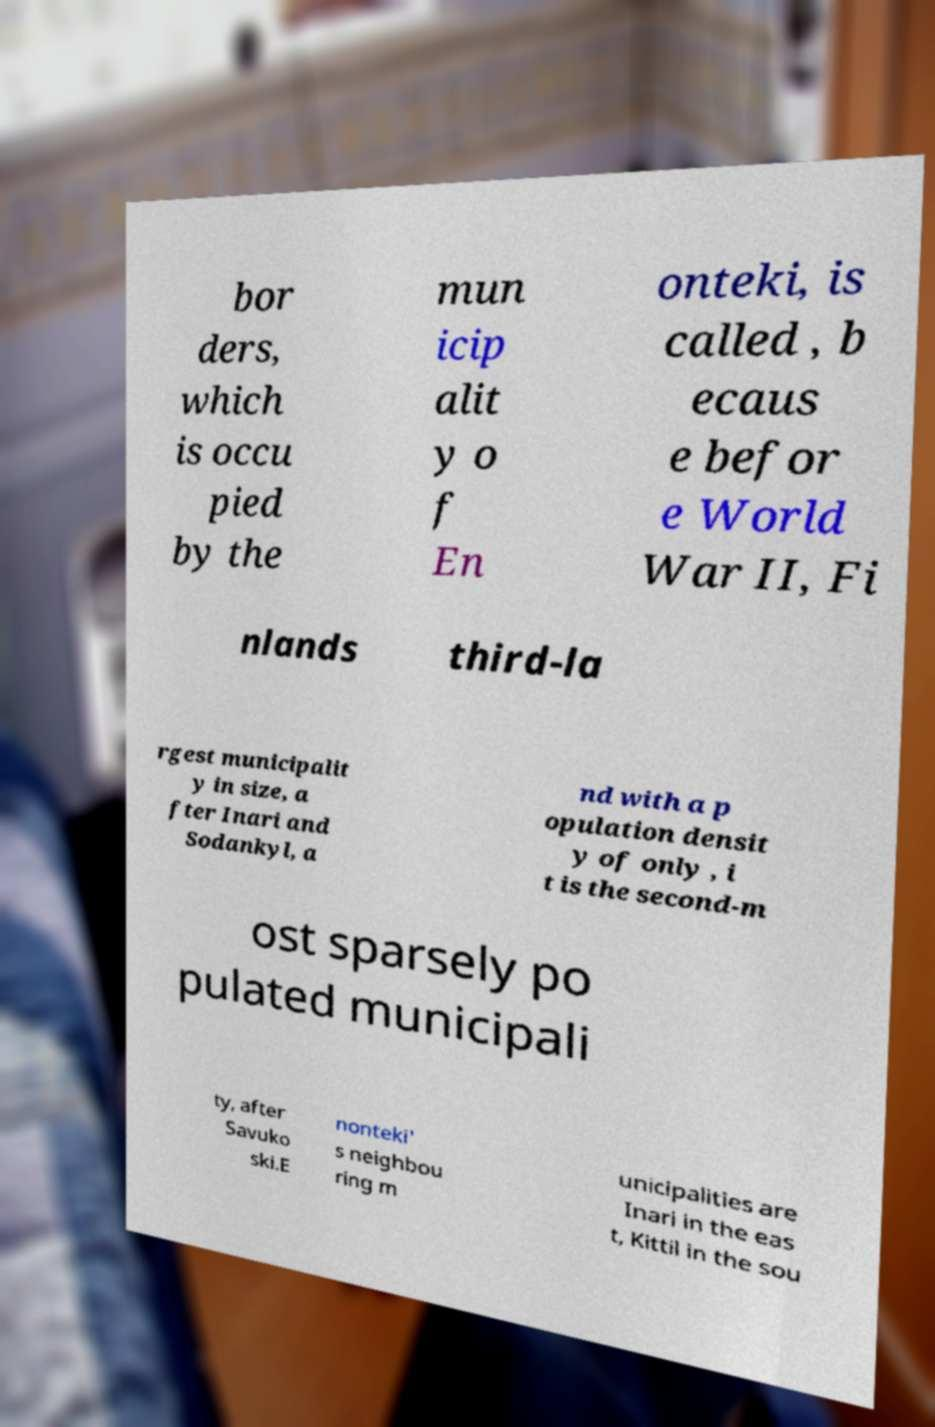I need the written content from this picture converted into text. Can you do that? bor ders, which is occu pied by the mun icip alit y o f En onteki, is called , b ecaus e befor e World War II, Fi nlands third-la rgest municipalit y in size, a fter Inari and Sodankyl, a nd with a p opulation densit y of only , i t is the second-m ost sparsely po pulated municipali ty, after Savuko ski.E nonteki' s neighbou ring m unicipalities are Inari in the eas t, Kittil in the sou 